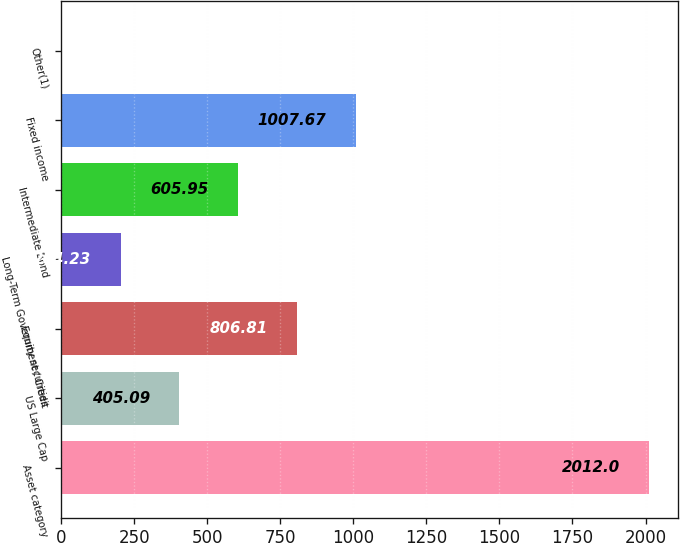Convert chart to OTSL. <chart><loc_0><loc_0><loc_500><loc_500><bar_chart><fcel>Asset category<fcel>US Large Cap<fcel>Equity securities<fcel>Long-Term Government / Credit<fcel>Intermediate Bond<fcel>Fixed income<fcel>Other(1)<nl><fcel>2012<fcel>405.09<fcel>806.81<fcel>204.23<fcel>605.95<fcel>1007.67<fcel>3.37<nl></chart> 